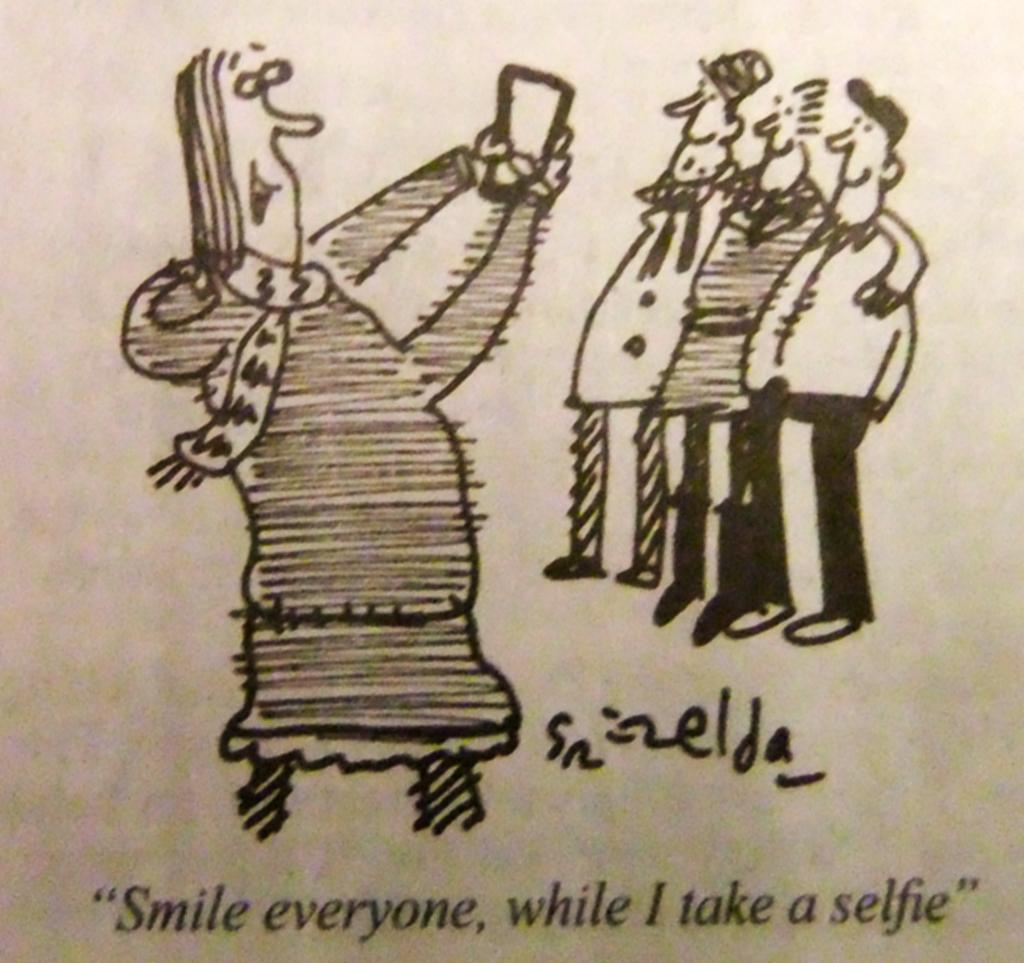What is depicted in the image? The image contains a sketch of a picture. What can be seen in the sketch? There are people standing in the sketch, and there is a person holding an object. Is there any text present in the sketch? Yes, there is text written on the sketch. What type of powder is being used by the person in the sketch? There is no powder mentioned or depicted in the sketch. 